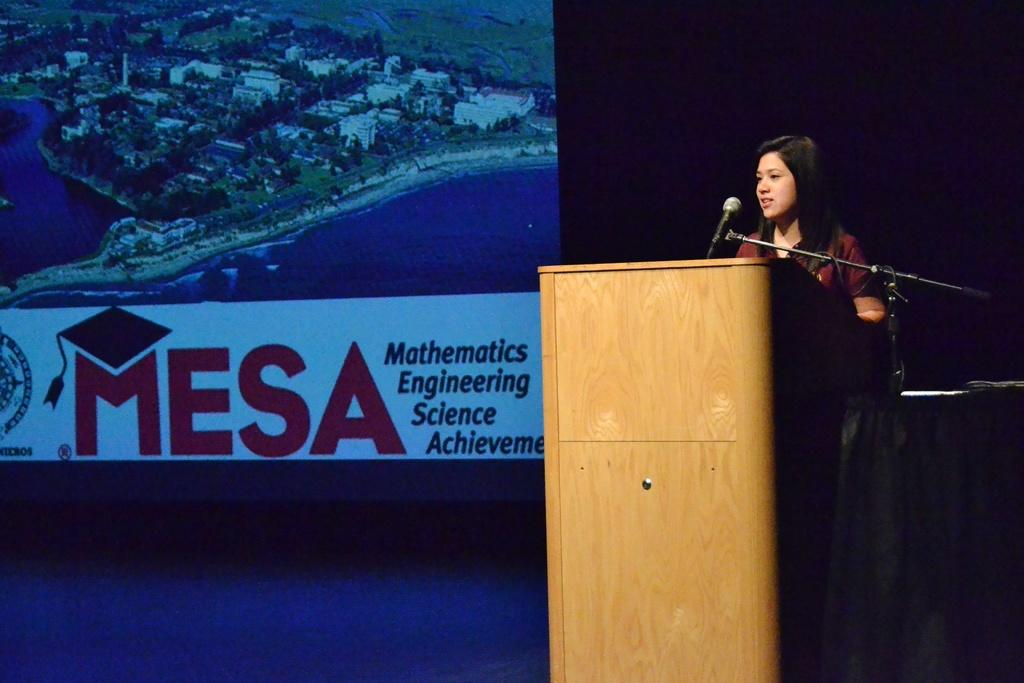What is the woman in the image doing? The woman is standing near a podium in the image. What equipment is present for the woman to use for speaking? There is a microphone with a microphone stand in the image. What can be seen in the background of the image? There is a screen visible in the background of the image. What type of guitar is the woman playing in the image? There is no guitar present in the image. 